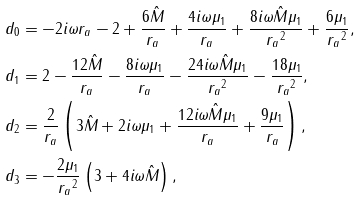Convert formula to latex. <formula><loc_0><loc_0><loc_500><loc_500>d _ { 0 } & = - 2 i \omega r _ { a } - 2 + \frac { 6 \hat { M } } { r _ { a } } + \frac { 4 i \omega \mu _ { 1 } } { r _ { a } } + \frac { 8 i \omega \hat { M } \mu _ { 1 } } { { r _ { a } } ^ { 2 } } + \frac { 6 \mu _ { 1 } } { { r _ { a } } ^ { 2 } } , \\ d _ { 1 } & = 2 - \frac { 1 2 \hat { M } } { r _ { a } } - \frac { 8 i \omega \mu _ { 1 } } { r _ { a } } - \frac { 2 4 i \omega \hat { M } \mu _ { 1 } } { { r _ { a } } ^ { 2 } } - \frac { 1 8 \mu _ { 1 } } { { r _ { a } } ^ { 2 } } , \\ d _ { 2 } & = \frac { 2 } { r _ { a } } \left ( 3 \hat { M } + 2 i \omega \mu _ { 1 } + \frac { 1 2 i \omega \hat { M } \mu _ { 1 } } { r _ { a } } + \frac { 9 \mu _ { 1 } } { r _ { a } } \right ) , \\ d _ { 3 } & = - \frac { 2 \mu _ { 1 } } { { r _ { a } } ^ { 2 } } \left ( 3 + 4 i \omega \hat { M } \right ) ,</formula> 